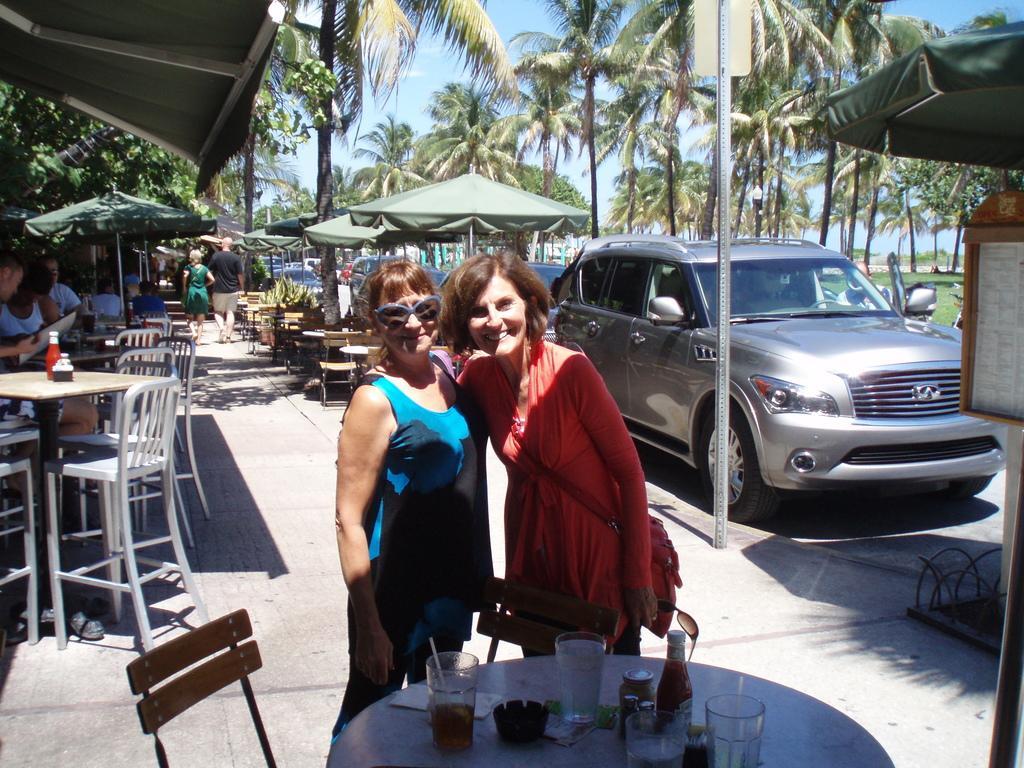In one or two sentences, can you explain what this image depicts? This image describes about group of people some are standing and some are seated on the chairs in the middle of the image two women are standing and laughing in front of them we can find glass and some food items on the table in the background we can see some tents cars sign boards and trees. 